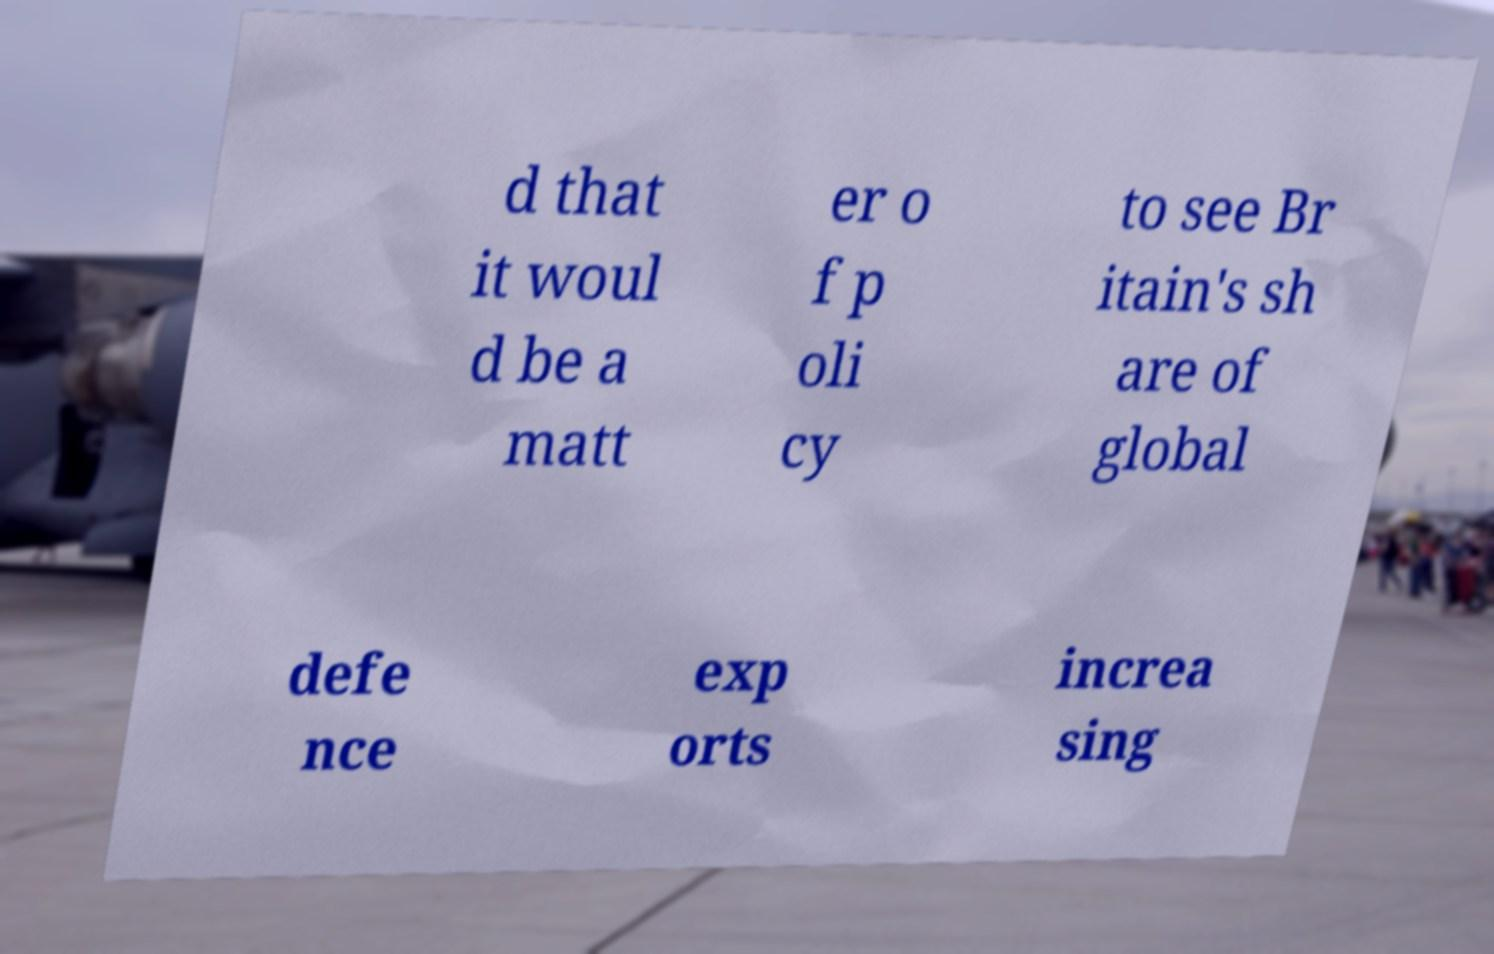Can you read and provide the text displayed in the image?This photo seems to have some interesting text. Can you extract and type it out for me? d that it woul d be a matt er o f p oli cy to see Br itain's sh are of global defe nce exp orts increa sing 